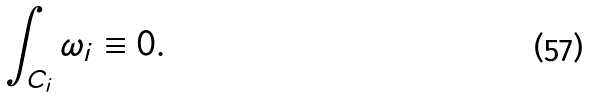<formula> <loc_0><loc_0><loc_500><loc_500>\int _ { C _ { i } } \omega _ { i } \equiv 0 .</formula> 